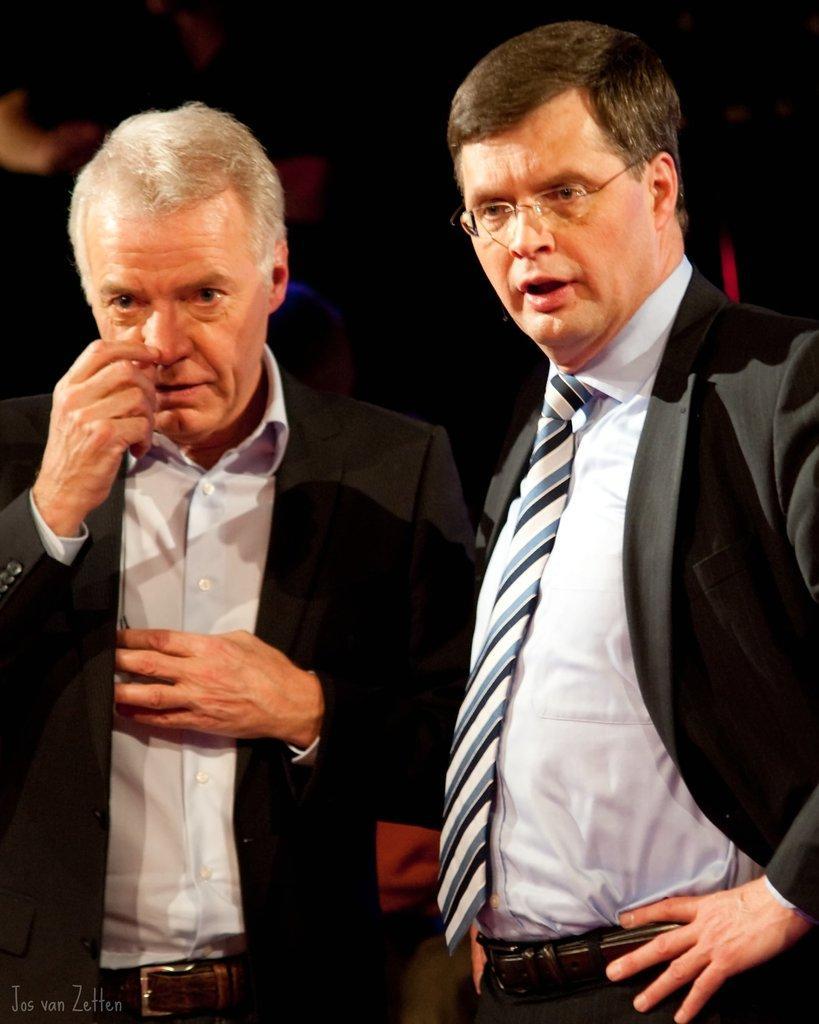Describe this image in one or two sentences. In this image there are two people standing , and there is a dark background and a watermark on the image. 